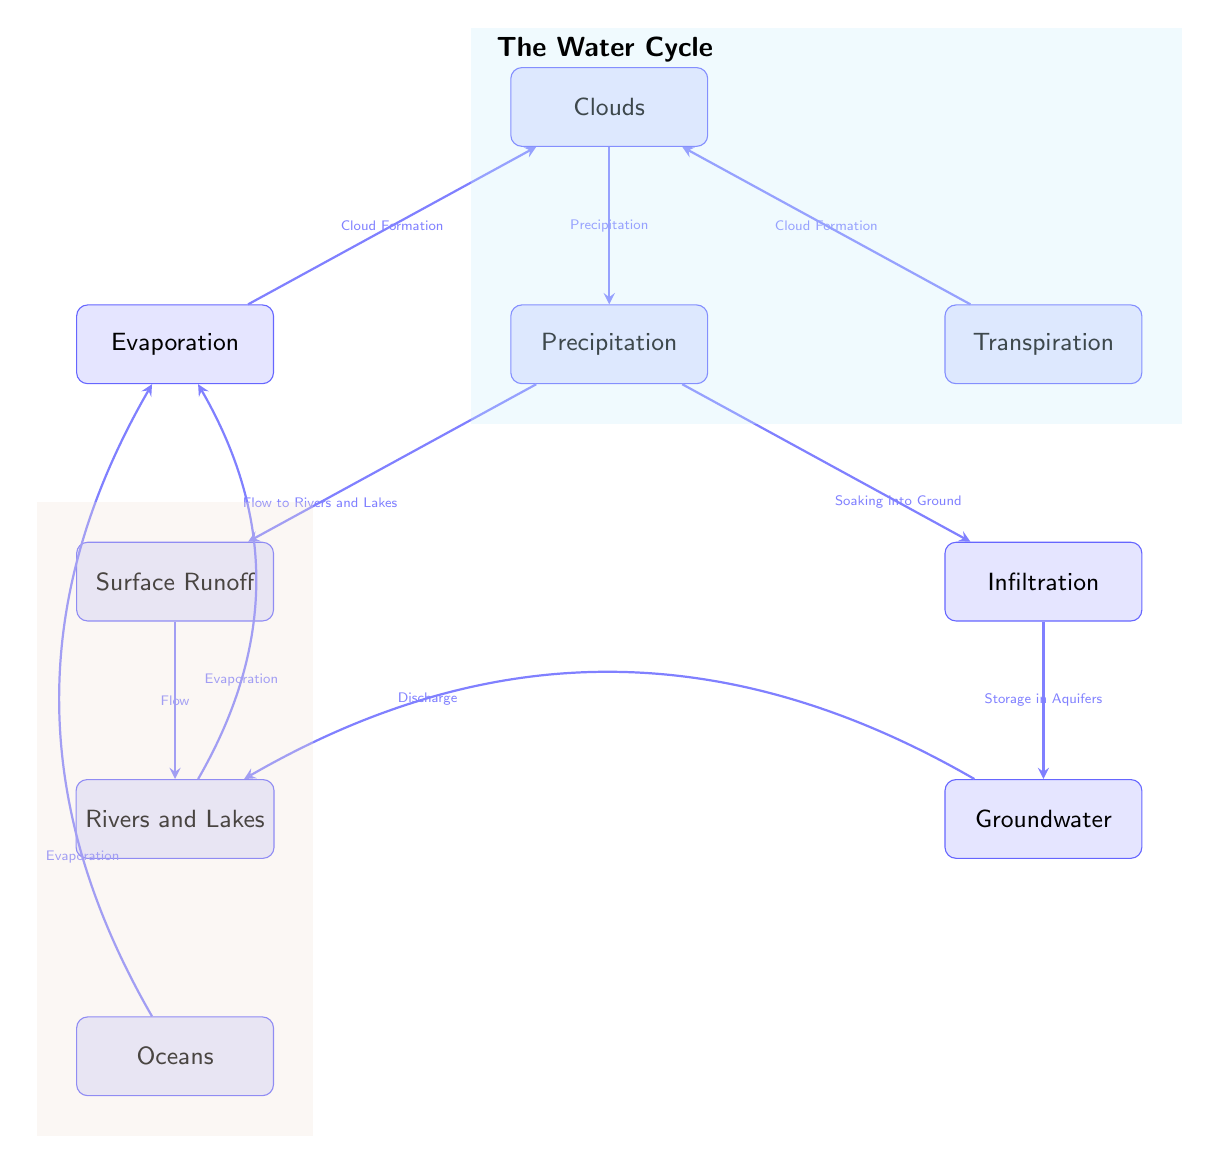What is the label of the node directly connected to Precipitation? The node directly connected to Precipitation is Surface Runoff, as indicated by the arrow that points from Precipitation to Surface Runoff in the diagram.
Answer: Surface Runoff How many main processes are involved in the water cycle as depicted in the diagram? The diagram includes a total of 7 main processes, which are Clouds, Precipitation, Evaporation, Transpiration, Surface Runoff, Infiltration, and Groundwater.
Answer: 7 What action is represented by the arrow going from Evaporation to Clouds? The label on the arrow between Evaporation and Clouds indicates the action 'Cloud Formation.' Therefore, it shows that Evaporation contributes to the formation of Clouds.
Answer: Cloud Formation Which two processes directly add water to Rivers and Lakes? The two processes that directly add water to Rivers and Lakes are Surface Runoff and Groundwater. Surface Runoff flows into Rivers and Lakes, while Groundwater discharges into them.
Answer: Surface Runoff and Groundwater What happens to water after it precipitates? After Precipitation, water can either flow to Rivers and Lakes (Surface Runoff) or soak into the ground (Infiltration), according to the arrows leading from the Precipitation node.
Answer: Flow to Rivers and Lakes and Soaking into Ground Which process has a direct output to Oceans? The process that has a direct output to Oceans is Evaporation, as shown by the arrow that bends left from Oceans to Evaporation, indicating that water from Oceans evaporates into the atmosphere.
Answer: Evaporation How does Transpiration contribute to Cloud Formation? Transpiration contributes to Cloud Formation by releasing water vapor into the atmosphere, which is represented by the arrow pointing from Transpiration to Clouds indicating this connection.
Answer: Cloud Formation What is the overall direction of water movement in the Water Cycle depicted in the diagram? The overall direction of water movement in the Water Cycle flows from Oceans to Evaporation, then through Clouds and Precipitation, leading to Surface Runoff and Infiltration, finally reaching Rivers and Lakes.
Answer: Downward and circular flow What role do Aquifers play according to the diagram? Aquifers play the role of storing water, as indicated by the arrow coming from Infiltration that leads to the Groundwater node, which represents storage in aquifers.
Answer: Storage in Aquifers 